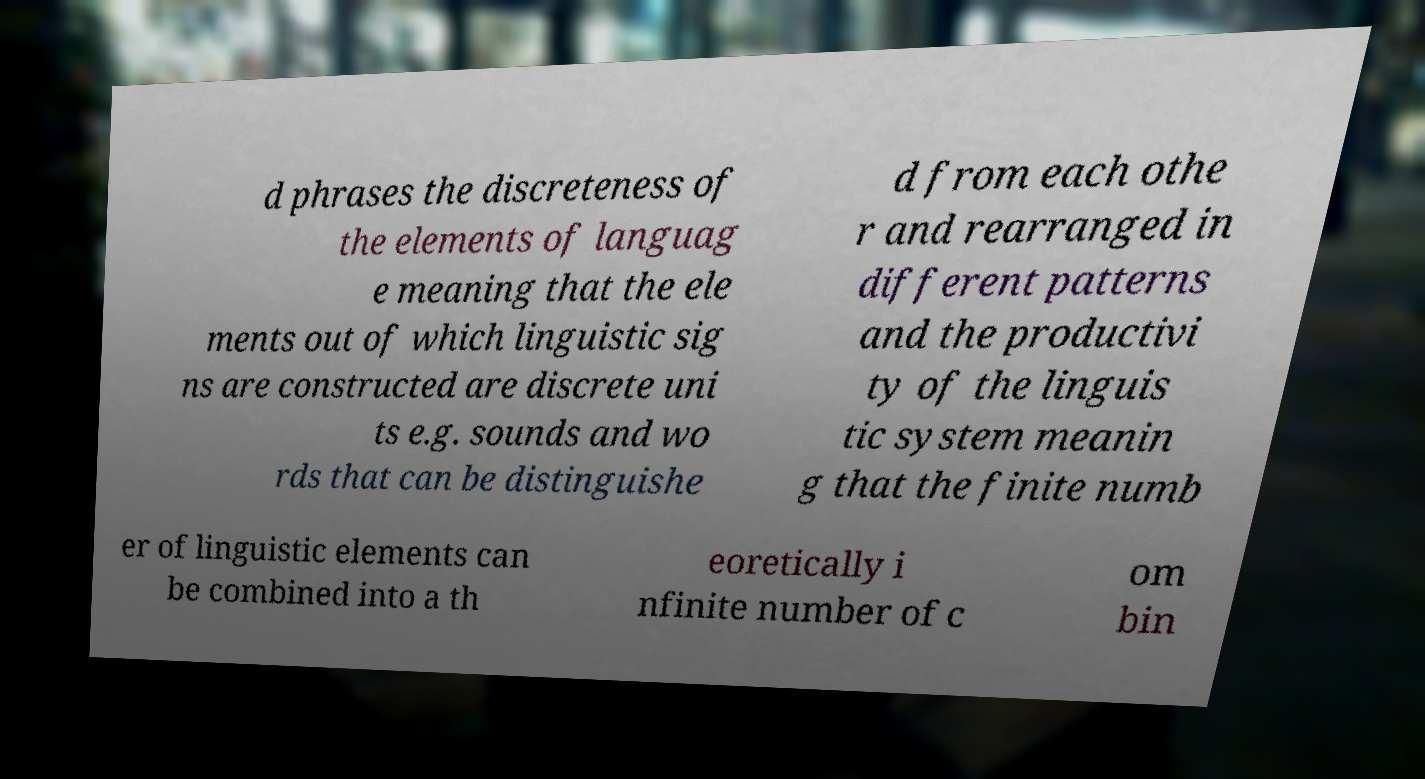Please read and relay the text visible in this image. What does it say? d phrases the discreteness of the elements of languag e meaning that the ele ments out of which linguistic sig ns are constructed are discrete uni ts e.g. sounds and wo rds that can be distinguishe d from each othe r and rearranged in different patterns and the productivi ty of the linguis tic system meanin g that the finite numb er of linguistic elements can be combined into a th eoretically i nfinite number of c om bin 